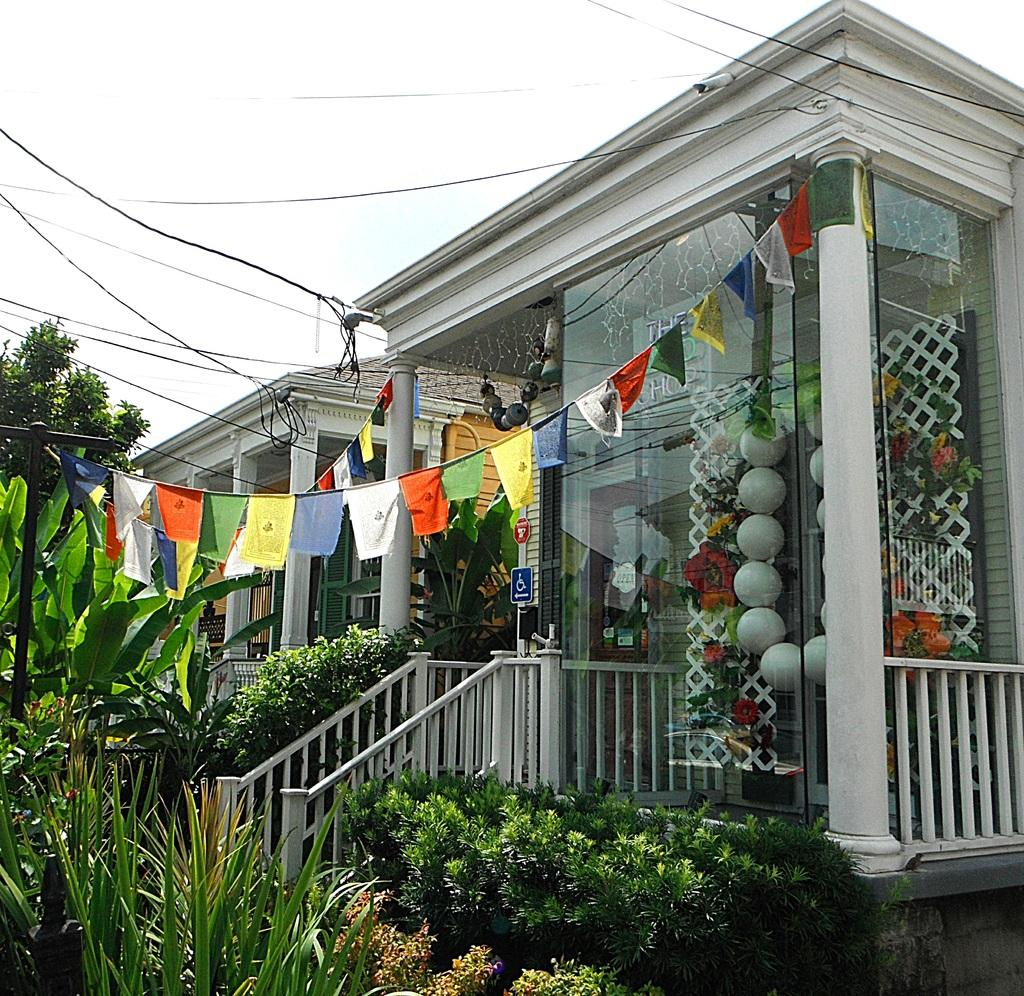What type of living organisms can be seen in the image? Plants and trees are visible in the image. What architectural feature can be seen in the image? There are stairs in the image. What type of structures are present in the image? There are buildings in the image. What part of the natural environment is visible in the image? The sky is visible in the image. What type of committee is meeting in the image? There is no committee meeting present in the image. Can you see a kitty playing in the image? There is no kitty present in the image. 